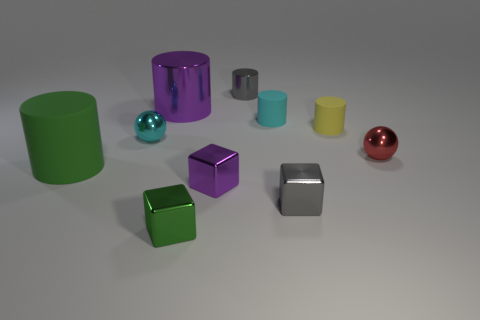Are there any tiny gray metallic cylinders in front of the cyan thing that is behind the yellow rubber cylinder to the right of the purple shiny cylinder?
Ensure brevity in your answer.  No. There is a big green cylinder; how many green objects are behind it?
Offer a terse response. 0. There is a block that is the same color as the small metallic cylinder; what material is it?
Provide a short and direct response. Metal. How many small objects are purple metallic things or red metallic objects?
Provide a succinct answer. 2. The green object behind the green cube has what shape?
Offer a terse response. Cylinder. Are there any matte cylinders of the same color as the big rubber thing?
Keep it short and to the point. No. Is the size of the purple cylinder on the left side of the small purple block the same as the cyan thing that is in front of the yellow thing?
Provide a succinct answer. No. Is the number of purple metal objects that are on the left side of the tiny cyan sphere greater than the number of tiny gray cubes behind the cyan cylinder?
Your answer should be very brief. No. Is there a green cylinder that has the same material as the red sphere?
Provide a succinct answer. No. Do the big shiny cylinder and the big matte cylinder have the same color?
Offer a terse response. No. 